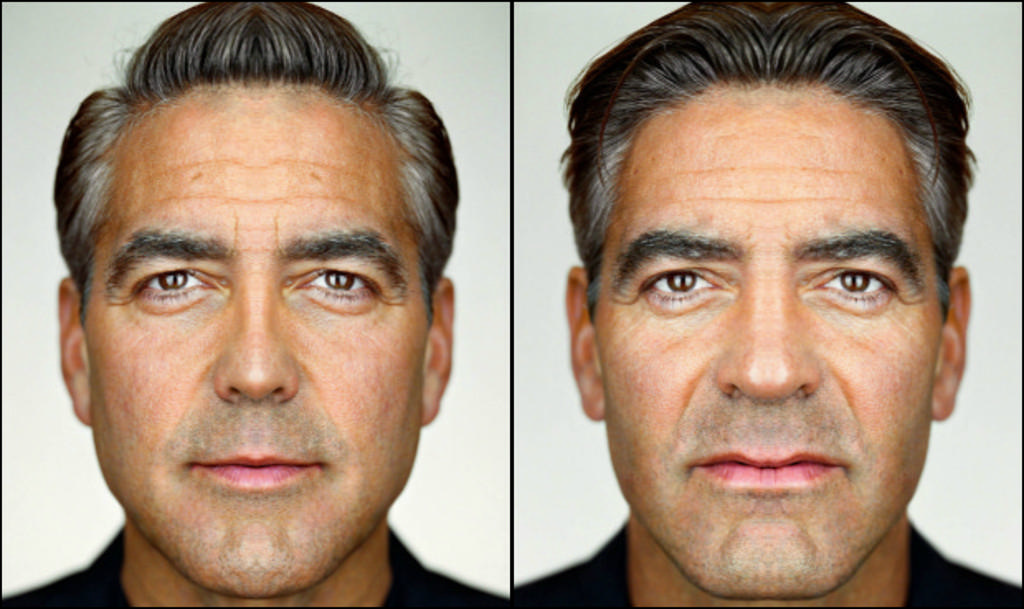Could you give a brief overview of what you see in this image? This is a photo grid image of a man of two besides each other. 